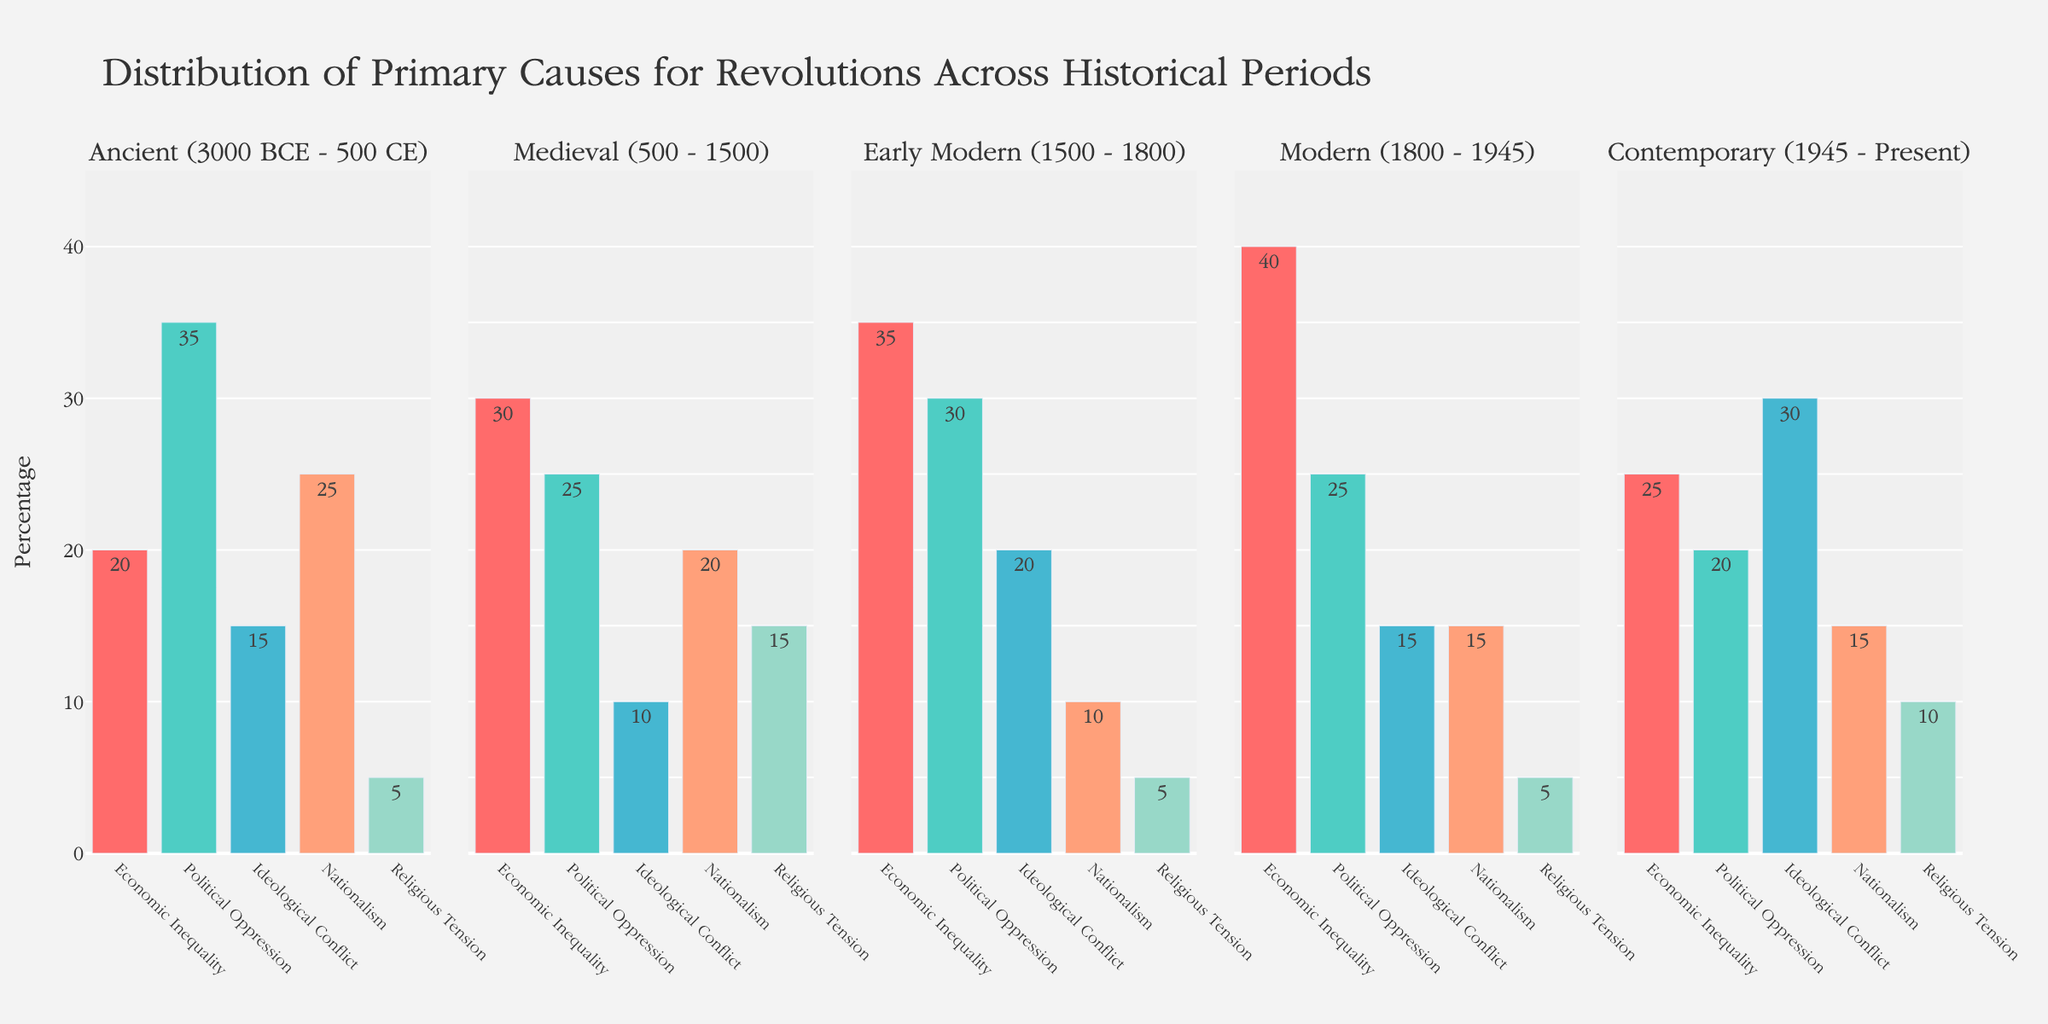What is the percentage of Nationalism as a cause for revolutions in the Medieval period? Look at the Medieval period subplot and identify the bar labeled 'Nationalism', which has a value of 20%.
Answer: 20% Which period shows the highest percentage for Ideological Conflict as a cause? Compare all the subplots, focusing on the bars labeled 'Ideological Conflict'. The Contemporary period has the highest value, at 30%.
Answer: Contemporary What is the average percentage of Economic Inequality as a cause across all periods? Add the values for 'Economic Inequality' from each period (20 + 30 + 35 + 40 + 25) and divide by the number of periods, which is 5. Thus, (20 + 30 + 35 + 40 + 25) / 5 = 30.
Answer: 30 Which period has the lowest percentage for Religious Tension and what is the value? Compare the 'Religious Tension' bars across all subplots. Both the Ancient and Early Modern periods have the lowest percentage of 5%.
Answer: Ancient, Early Modern How does the percentage of Political Oppression in the Early Modern period compare to that in the Ancient period? Identify the 'Political Oppression' bar in the Early Modern period (30%) and in the Ancient period (35%). The Early Modern value is 5% lower than the Ancient value.
Answer: It is 5% lower What is the total percentage for causes related to Nationalism and Religious Tension in the Contemporary period? Add the values for 'Nationalism' (15%) and 'Religious Tension' (10%) in the Contemporary period: 15 + 10 = 25%.
Answer: 25% In which period is Economic Inequality least significant, and what is its percentage? Compare the 'Economic Inequality' values across all subplots. The Ancient period shows the lowest value with 20%.
Answer: Ancient, 20% If you sum the percentages for Political Oppression and Ideological Conflict in the Modern period, what is the result? Look at the values for 'Political Oppression' (25%) and 'Ideological Conflict' (15%) in the Modern period, and add them: 25 + 15 = 40%.
Answer: 40% During the Early Modern period, which cause has the smallest percentage and what is it? Identify the smallest bar in the Early Modern subplot, labeled 'Religious Tension', with a value of 5%.
Answer: Religious Tension, 5% 